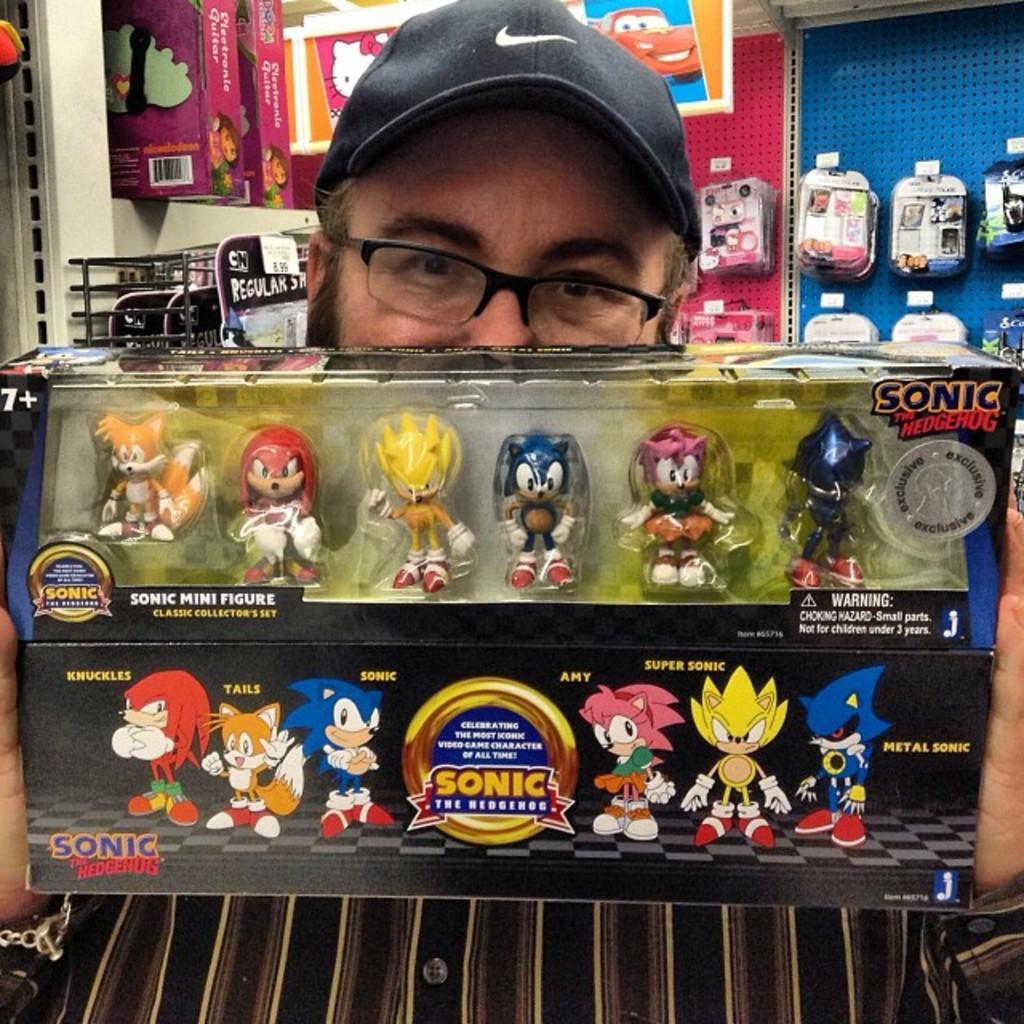Please provide a concise description of this image. In the center of this picture we can see a man wearing a cap and holding a box containing toys and we can see the text and pictures of the toys on the box. In the background we can see the wall, metal rods and the boxes and many other objects and we can see the pictures of the cartoons on the boxes. 